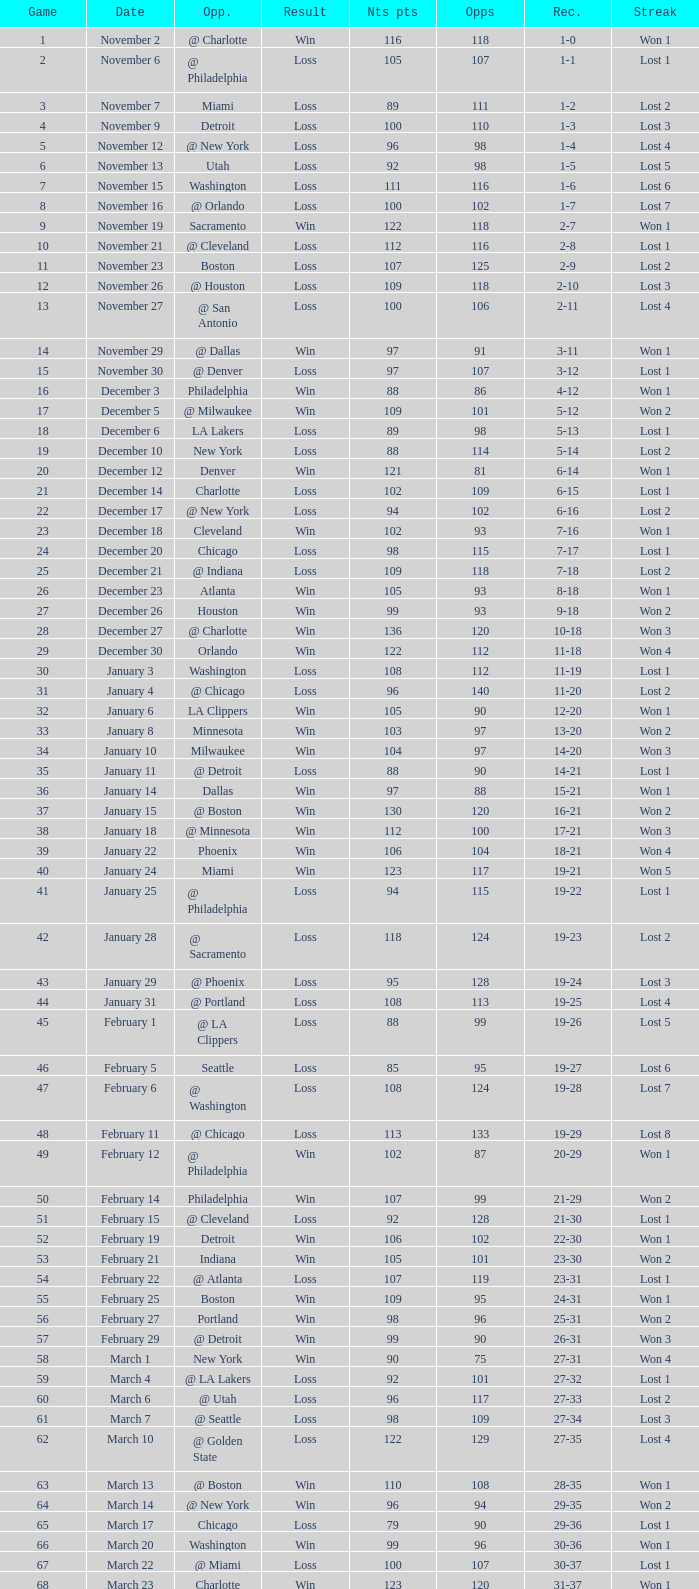Write the full table. {'header': ['Game', 'Date', 'Opp.', 'Result', 'Nts pts', 'Opps', 'Rec.', 'Streak'], 'rows': [['1', 'November 2', '@ Charlotte', 'Win', '116', '118', '1-0', 'Won 1'], ['2', 'November 6', '@ Philadelphia', 'Loss', '105', '107', '1-1', 'Lost 1'], ['3', 'November 7', 'Miami', 'Loss', '89', '111', '1-2', 'Lost 2'], ['4', 'November 9', 'Detroit', 'Loss', '100', '110', '1-3', 'Lost 3'], ['5', 'November 12', '@ New York', 'Loss', '96', '98', '1-4', 'Lost 4'], ['6', 'November 13', 'Utah', 'Loss', '92', '98', '1-5', 'Lost 5'], ['7', 'November 15', 'Washington', 'Loss', '111', '116', '1-6', 'Lost 6'], ['8', 'November 16', '@ Orlando', 'Loss', '100', '102', '1-7', 'Lost 7'], ['9', 'November 19', 'Sacramento', 'Win', '122', '118', '2-7', 'Won 1'], ['10', 'November 21', '@ Cleveland', 'Loss', '112', '116', '2-8', 'Lost 1'], ['11', 'November 23', 'Boston', 'Loss', '107', '125', '2-9', 'Lost 2'], ['12', 'November 26', '@ Houston', 'Loss', '109', '118', '2-10', 'Lost 3'], ['13', 'November 27', '@ San Antonio', 'Loss', '100', '106', '2-11', 'Lost 4'], ['14', 'November 29', '@ Dallas', 'Win', '97', '91', '3-11', 'Won 1'], ['15', 'November 30', '@ Denver', 'Loss', '97', '107', '3-12', 'Lost 1'], ['16', 'December 3', 'Philadelphia', 'Win', '88', '86', '4-12', 'Won 1'], ['17', 'December 5', '@ Milwaukee', 'Win', '109', '101', '5-12', 'Won 2'], ['18', 'December 6', 'LA Lakers', 'Loss', '89', '98', '5-13', 'Lost 1'], ['19', 'December 10', 'New York', 'Loss', '88', '114', '5-14', 'Lost 2'], ['20', 'December 12', 'Denver', 'Win', '121', '81', '6-14', 'Won 1'], ['21', 'December 14', 'Charlotte', 'Loss', '102', '109', '6-15', 'Lost 1'], ['22', 'December 17', '@ New York', 'Loss', '94', '102', '6-16', 'Lost 2'], ['23', 'December 18', 'Cleveland', 'Win', '102', '93', '7-16', 'Won 1'], ['24', 'December 20', 'Chicago', 'Loss', '98', '115', '7-17', 'Lost 1'], ['25', 'December 21', '@ Indiana', 'Loss', '109', '118', '7-18', 'Lost 2'], ['26', 'December 23', 'Atlanta', 'Win', '105', '93', '8-18', 'Won 1'], ['27', 'December 26', 'Houston', 'Win', '99', '93', '9-18', 'Won 2'], ['28', 'December 27', '@ Charlotte', 'Win', '136', '120', '10-18', 'Won 3'], ['29', 'December 30', 'Orlando', 'Win', '122', '112', '11-18', 'Won 4'], ['30', 'January 3', 'Washington', 'Loss', '108', '112', '11-19', 'Lost 1'], ['31', 'January 4', '@ Chicago', 'Loss', '96', '140', '11-20', 'Lost 2'], ['32', 'January 6', 'LA Clippers', 'Win', '105', '90', '12-20', 'Won 1'], ['33', 'January 8', 'Minnesota', 'Win', '103', '97', '13-20', 'Won 2'], ['34', 'January 10', 'Milwaukee', 'Win', '104', '97', '14-20', 'Won 3'], ['35', 'January 11', '@ Detroit', 'Loss', '88', '90', '14-21', 'Lost 1'], ['36', 'January 14', 'Dallas', 'Win', '97', '88', '15-21', 'Won 1'], ['37', 'January 15', '@ Boston', 'Win', '130', '120', '16-21', 'Won 2'], ['38', 'January 18', '@ Minnesota', 'Win', '112', '100', '17-21', 'Won 3'], ['39', 'January 22', 'Phoenix', 'Win', '106', '104', '18-21', 'Won 4'], ['40', 'January 24', 'Miami', 'Win', '123', '117', '19-21', 'Won 5'], ['41', 'January 25', '@ Philadelphia', 'Loss', '94', '115', '19-22', 'Lost 1'], ['42', 'January 28', '@ Sacramento', 'Loss', '118', '124', '19-23', 'Lost 2'], ['43', 'January 29', '@ Phoenix', 'Loss', '95', '128', '19-24', 'Lost 3'], ['44', 'January 31', '@ Portland', 'Loss', '108', '113', '19-25', 'Lost 4'], ['45', 'February 1', '@ LA Clippers', 'Loss', '88', '99', '19-26', 'Lost 5'], ['46', 'February 5', 'Seattle', 'Loss', '85', '95', '19-27', 'Lost 6'], ['47', 'February 6', '@ Washington', 'Loss', '108', '124', '19-28', 'Lost 7'], ['48', 'February 11', '@ Chicago', 'Loss', '113', '133', '19-29', 'Lost 8'], ['49', 'February 12', '@ Philadelphia', 'Win', '102', '87', '20-29', 'Won 1'], ['50', 'February 14', 'Philadelphia', 'Win', '107', '99', '21-29', 'Won 2'], ['51', 'February 15', '@ Cleveland', 'Loss', '92', '128', '21-30', 'Lost 1'], ['52', 'February 19', 'Detroit', 'Win', '106', '102', '22-30', 'Won 1'], ['53', 'February 21', 'Indiana', 'Win', '105', '101', '23-30', 'Won 2'], ['54', 'February 22', '@ Atlanta', 'Loss', '107', '119', '23-31', 'Lost 1'], ['55', 'February 25', 'Boston', 'Win', '109', '95', '24-31', 'Won 1'], ['56', 'February 27', 'Portland', 'Win', '98', '96', '25-31', 'Won 2'], ['57', 'February 29', '@ Detroit', 'Win', '99', '90', '26-31', 'Won 3'], ['58', 'March 1', 'New York', 'Win', '90', '75', '27-31', 'Won 4'], ['59', 'March 4', '@ LA Lakers', 'Loss', '92', '101', '27-32', 'Lost 1'], ['60', 'March 6', '@ Utah', 'Loss', '96', '117', '27-33', 'Lost 2'], ['61', 'March 7', '@ Seattle', 'Loss', '98', '109', '27-34', 'Lost 3'], ['62', 'March 10', '@ Golden State', 'Loss', '122', '129', '27-35', 'Lost 4'], ['63', 'March 13', '@ Boston', 'Win', '110', '108', '28-35', 'Won 1'], ['64', 'March 14', '@ New York', 'Win', '96', '94', '29-35', 'Won 2'], ['65', 'March 17', 'Chicago', 'Loss', '79', '90', '29-36', 'Lost 1'], ['66', 'March 20', 'Washington', 'Win', '99', '96', '30-36', 'Won 1'], ['67', 'March 22', '@ Miami', 'Loss', '100', '107', '30-37', 'Lost 1'], ['68', 'March 23', 'Charlotte', 'Win', '123', '120', '31-37', 'Won 1'], ['69', 'March 25', 'Boston', 'Loss', '110', '118', '31-38', 'Lost 1'], ['70', 'March 28', 'Golden State', 'Loss', '148', '153', '31-39', 'Lost 2'], ['71', 'March 30', 'San Antonio', 'Win', '117', '109', '32-39', 'Won 1'], ['72', 'April 1', '@ Milwaukee', 'Win', '121', '117', '33-39', 'Won 2'], ['73', 'April 3', 'Milwaukee', 'Win', '122', '103', '34-39', 'Won 3'], ['74', 'April 5', '@ Indiana', 'Win', '128', '120', '35-39', 'Won 4'], ['75', 'April 7', 'Atlanta', 'Loss', '97', '104', '35-40', 'Lost 1'], ['76', 'April 8', '@ Washington', 'Win', '109', '103', '36-40', 'Won 1'], ['77', 'April 10', 'Cleveland', 'Win', '110', '86', '37-40', 'Won 2'], ['78', 'April 11', '@ Atlanta', 'Loss', '98', '118', '37-41', 'Lost 1'], ['79', 'April 13', '@ Orlando', 'Win', '110', '104', '38-41', 'Won 1'], ['80', 'April 14', '@ Miami', 'Win', '105', '100', '39-41', 'Won 2'], ['81', 'April 16', 'Indiana', 'Loss', '113', '119', '39-42', 'Lost 1'], ['82', 'April 18', 'Orlando', 'Win', '127', '111', '40-42', 'Won 1'], ['1', 'April 23', '@ Cleveland', 'Loss', '113', '120', '0-1', 'Lost 1'], ['2', 'April 25', '@ Cleveland', 'Loss', '96', '118', '0-2', 'Lost 2'], ['3', 'April 28', 'Cleveland', 'Win', '109', '104', '1-2', 'Won 1'], ['4', 'April 30', 'Cleveland', 'Loss', '89', '98', '1-3', 'Lost 1']]} Which opponent is from february 12? @ Philadelphia. 